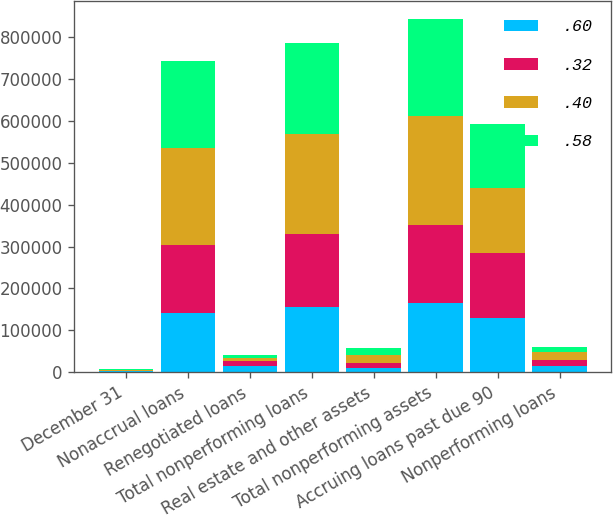Convert chart. <chart><loc_0><loc_0><loc_500><loc_500><stacked_bar_chart><ecel><fcel>December 31<fcel>Nonaccrual loans<fcel>Renegotiated loans<fcel>Total nonperforming loans<fcel>Real estate and other assets<fcel>Total nonperforming assets<fcel>Accruing loans past due 90<fcel>Nonperforming loans<nl><fcel>0.6<fcel>2005<fcel>141067<fcel>15384<fcel>156451<fcel>9486<fcel>165937<fcel>129403<fcel>13845<nl><fcel>0.32<fcel>2004<fcel>162013<fcel>10437<fcel>172450<fcel>12504<fcel>184954<fcel>154590<fcel>15273<nl><fcel>0.4<fcel>2003<fcel>232983<fcel>7309<fcel>240292<fcel>19629<fcel>259921<fcel>154759<fcel>19355<nl><fcel>0.58<fcel>2002<fcel>207038<fcel>8252<fcel>215290<fcel>17380<fcel>232670<fcel>153803<fcel>11885<nl></chart> 